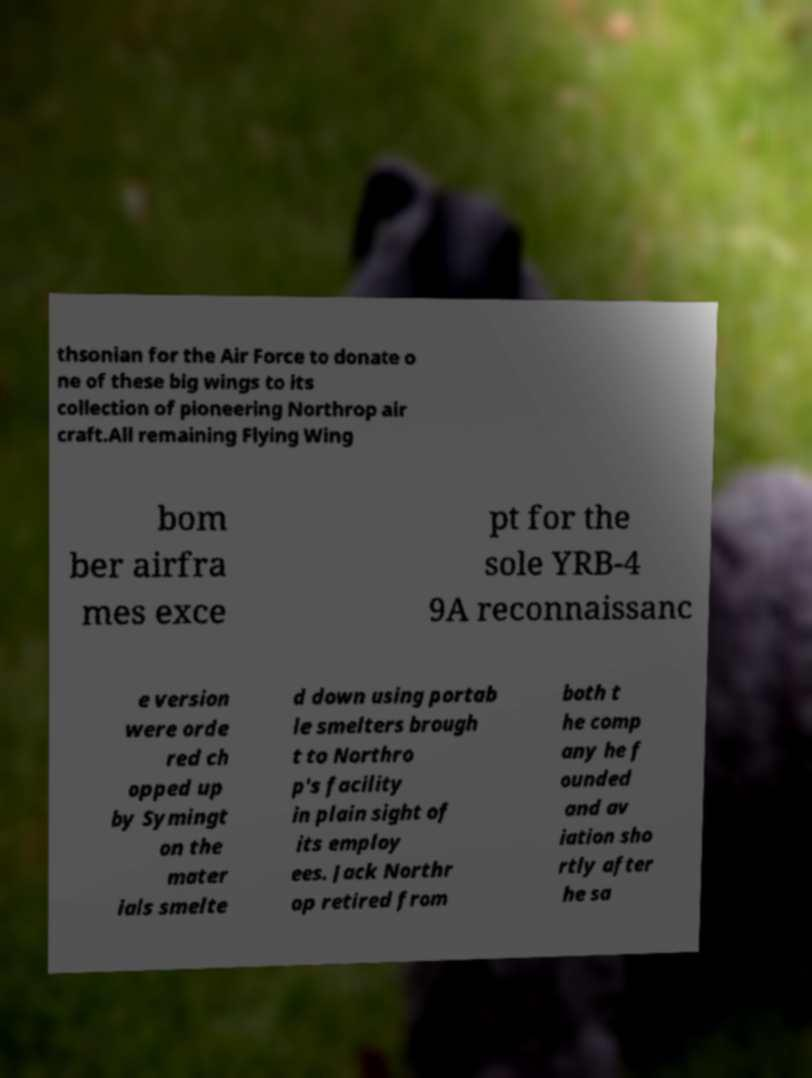Could you assist in decoding the text presented in this image and type it out clearly? thsonian for the Air Force to donate o ne of these big wings to its collection of pioneering Northrop air craft.All remaining Flying Wing bom ber airfra mes exce pt for the sole YRB-4 9A reconnaissanc e version were orde red ch opped up by Symingt on the mater ials smelte d down using portab le smelters brough t to Northro p's facility in plain sight of its employ ees. Jack Northr op retired from both t he comp any he f ounded and av iation sho rtly after he sa 